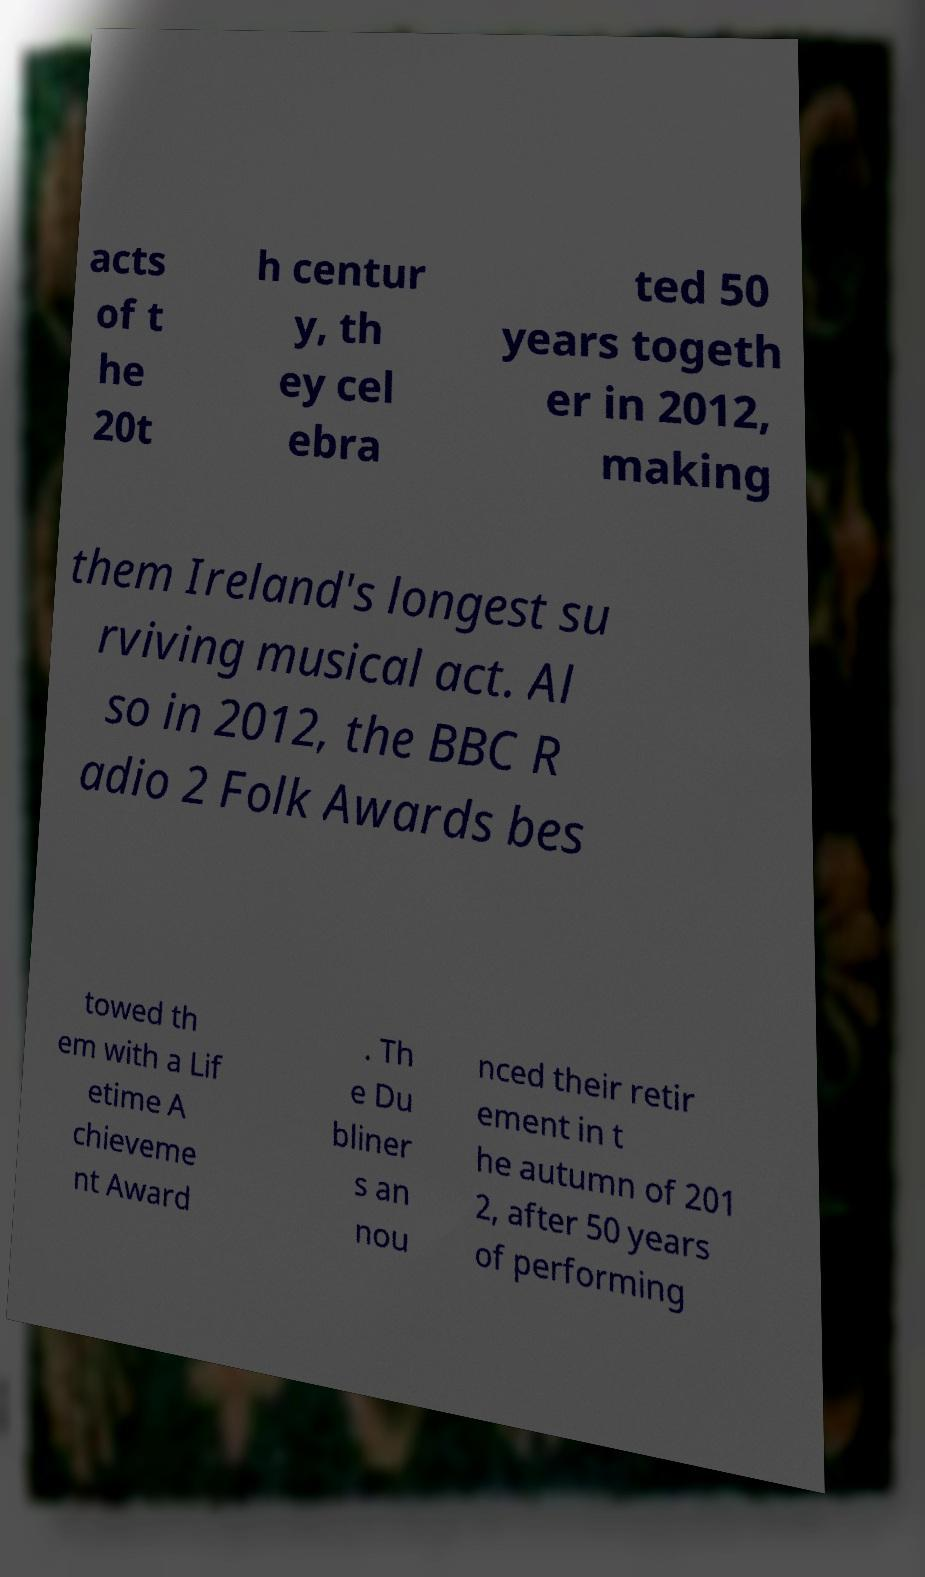Please identify and transcribe the text found in this image. acts of t he 20t h centur y, th ey cel ebra ted 50 years togeth er in 2012, making them Ireland's longest su rviving musical act. Al so in 2012, the BBC R adio 2 Folk Awards bes towed th em with a Lif etime A chieveme nt Award . Th e Du bliner s an nou nced their retir ement in t he autumn of 201 2, after 50 years of performing 